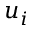Convert formula to latex. <formula><loc_0><loc_0><loc_500><loc_500>u _ { i }</formula> 